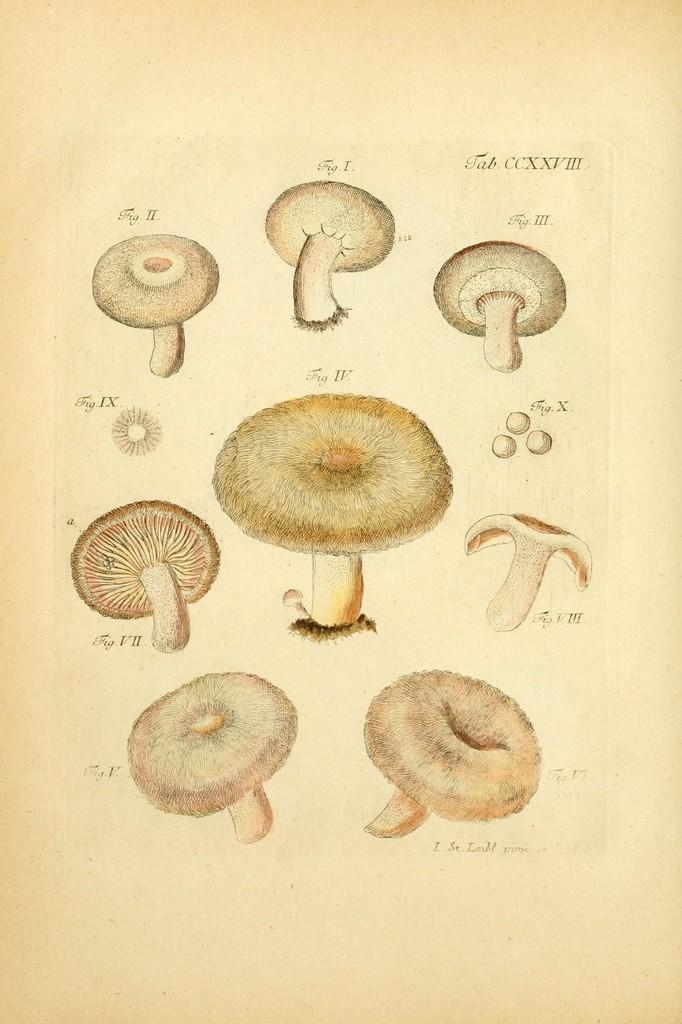Describe this image in one or two sentences. In this image I can see drawings of mushrooms on a paper. 